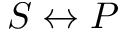<formula> <loc_0><loc_0><loc_500><loc_500>S \leftrightarrow P</formula> 